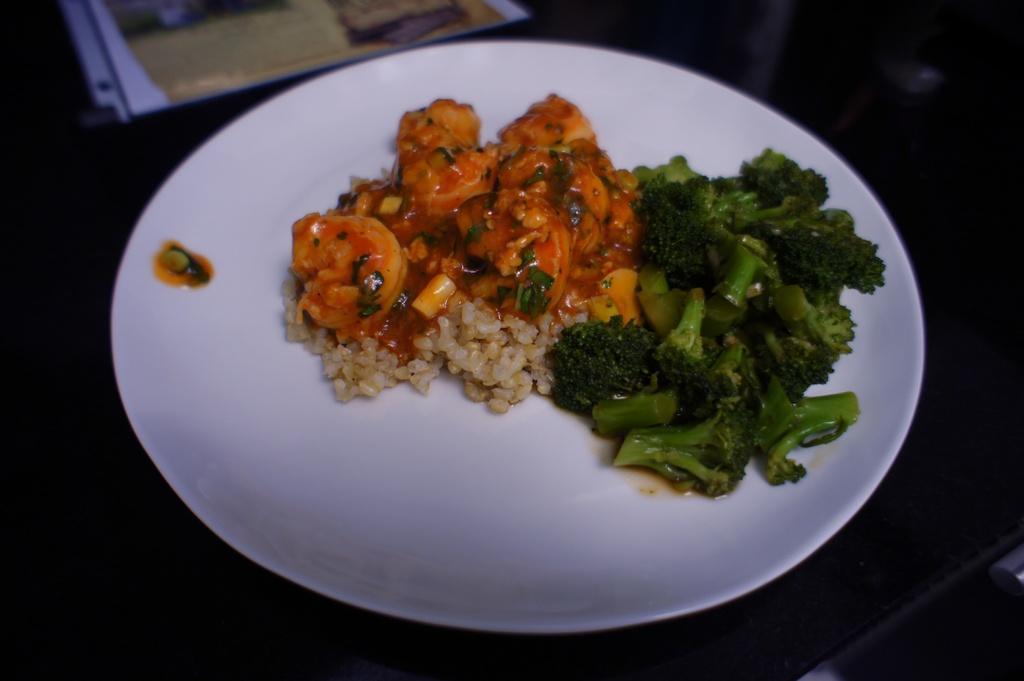Describe this image in one or two sentences. In this image there are broccoli pieces and food items in a white color plate. 